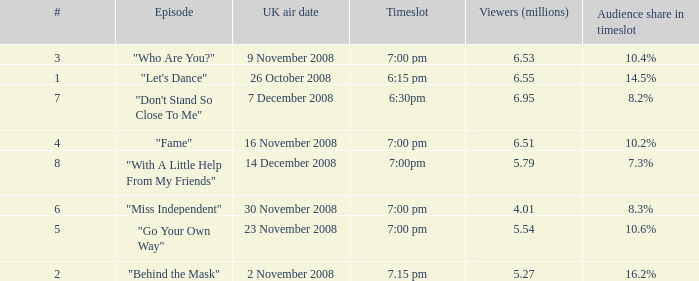Name the timeslot for 6.51 viewers 7:00 pm. 